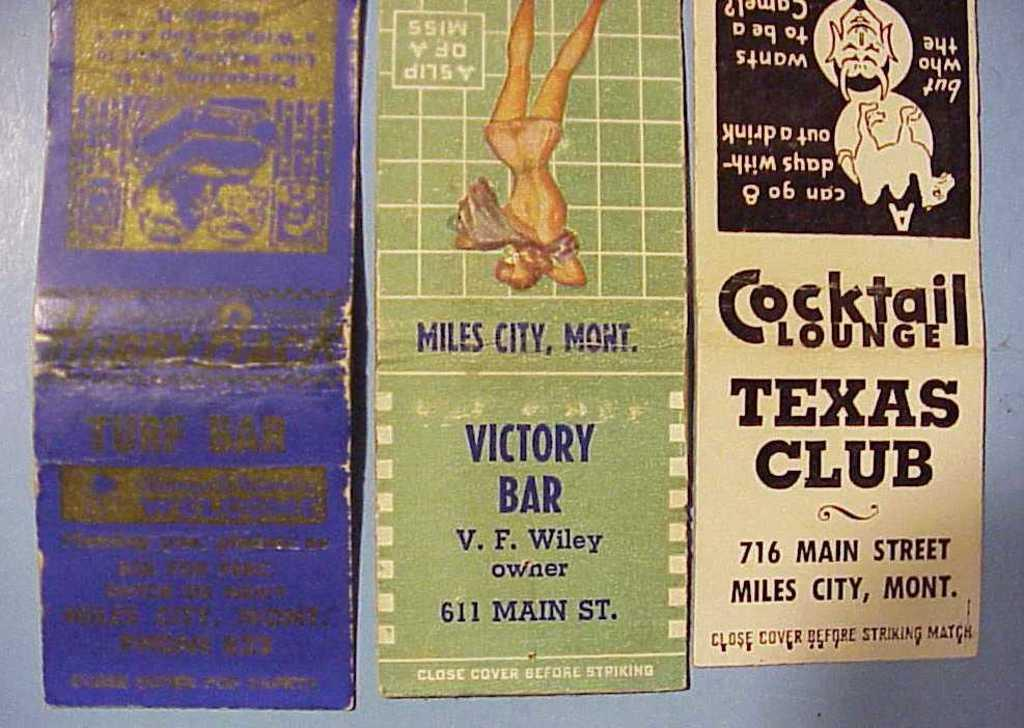<image>
Summarize the visual content of the image. Three old book marks with one that says Cocktail Lounge Texas Club. 